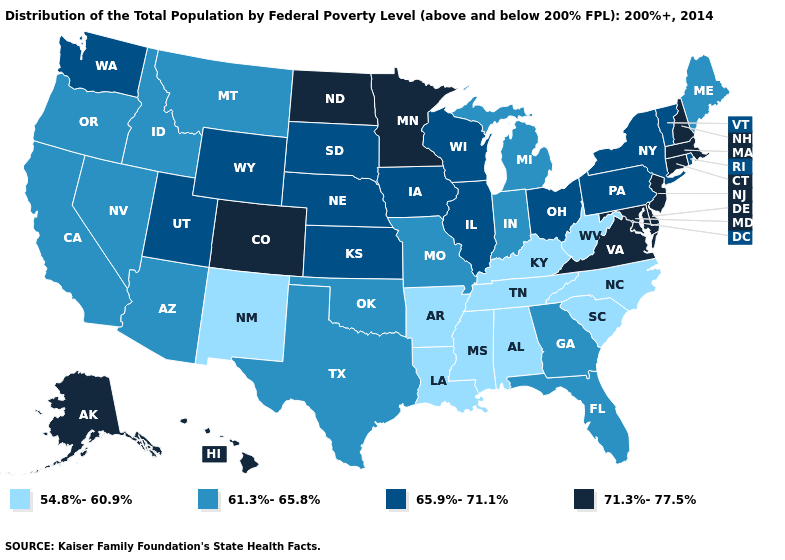Which states have the lowest value in the USA?
Answer briefly. Alabama, Arkansas, Kentucky, Louisiana, Mississippi, New Mexico, North Carolina, South Carolina, Tennessee, West Virginia. Among the states that border New Hampshire , which have the highest value?
Be succinct. Massachusetts. Among the states that border South Dakota , does Minnesota have the highest value?
Be succinct. Yes. Which states hav the highest value in the MidWest?
Give a very brief answer. Minnesota, North Dakota. Does New Jersey have the highest value in the Northeast?
Answer briefly. Yes. What is the value of Massachusetts?
Answer briefly. 71.3%-77.5%. What is the value of Mississippi?
Concise answer only. 54.8%-60.9%. What is the value of Ohio?
Answer briefly. 65.9%-71.1%. How many symbols are there in the legend?
Keep it brief. 4. Name the states that have a value in the range 65.9%-71.1%?
Answer briefly. Illinois, Iowa, Kansas, Nebraska, New York, Ohio, Pennsylvania, Rhode Island, South Dakota, Utah, Vermont, Washington, Wisconsin, Wyoming. Among the states that border Texas , does Louisiana have the lowest value?
Keep it brief. Yes. Does the first symbol in the legend represent the smallest category?
Short answer required. Yes. Among the states that border North Carolina , which have the highest value?
Short answer required. Virginia. What is the lowest value in the USA?
Answer briefly. 54.8%-60.9%. Name the states that have a value in the range 71.3%-77.5%?
Short answer required. Alaska, Colorado, Connecticut, Delaware, Hawaii, Maryland, Massachusetts, Minnesota, New Hampshire, New Jersey, North Dakota, Virginia. 